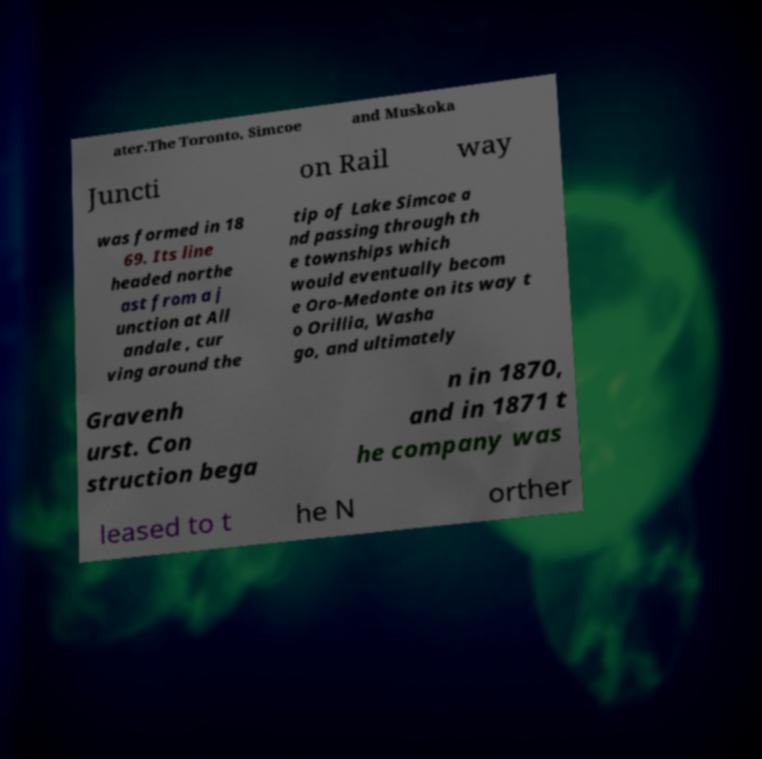There's text embedded in this image that I need extracted. Can you transcribe it verbatim? ater.The Toronto, Simcoe and Muskoka Juncti on Rail way was formed in 18 69. Its line headed northe ast from a j unction at All andale , cur ving around the tip of Lake Simcoe a nd passing through th e townships which would eventually becom e Oro-Medonte on its way t o Orillia, Washa go, and ultimately Gravenh urst. Con struction bega n in 1870, and in 1871 t he company was leased to t he N orther 